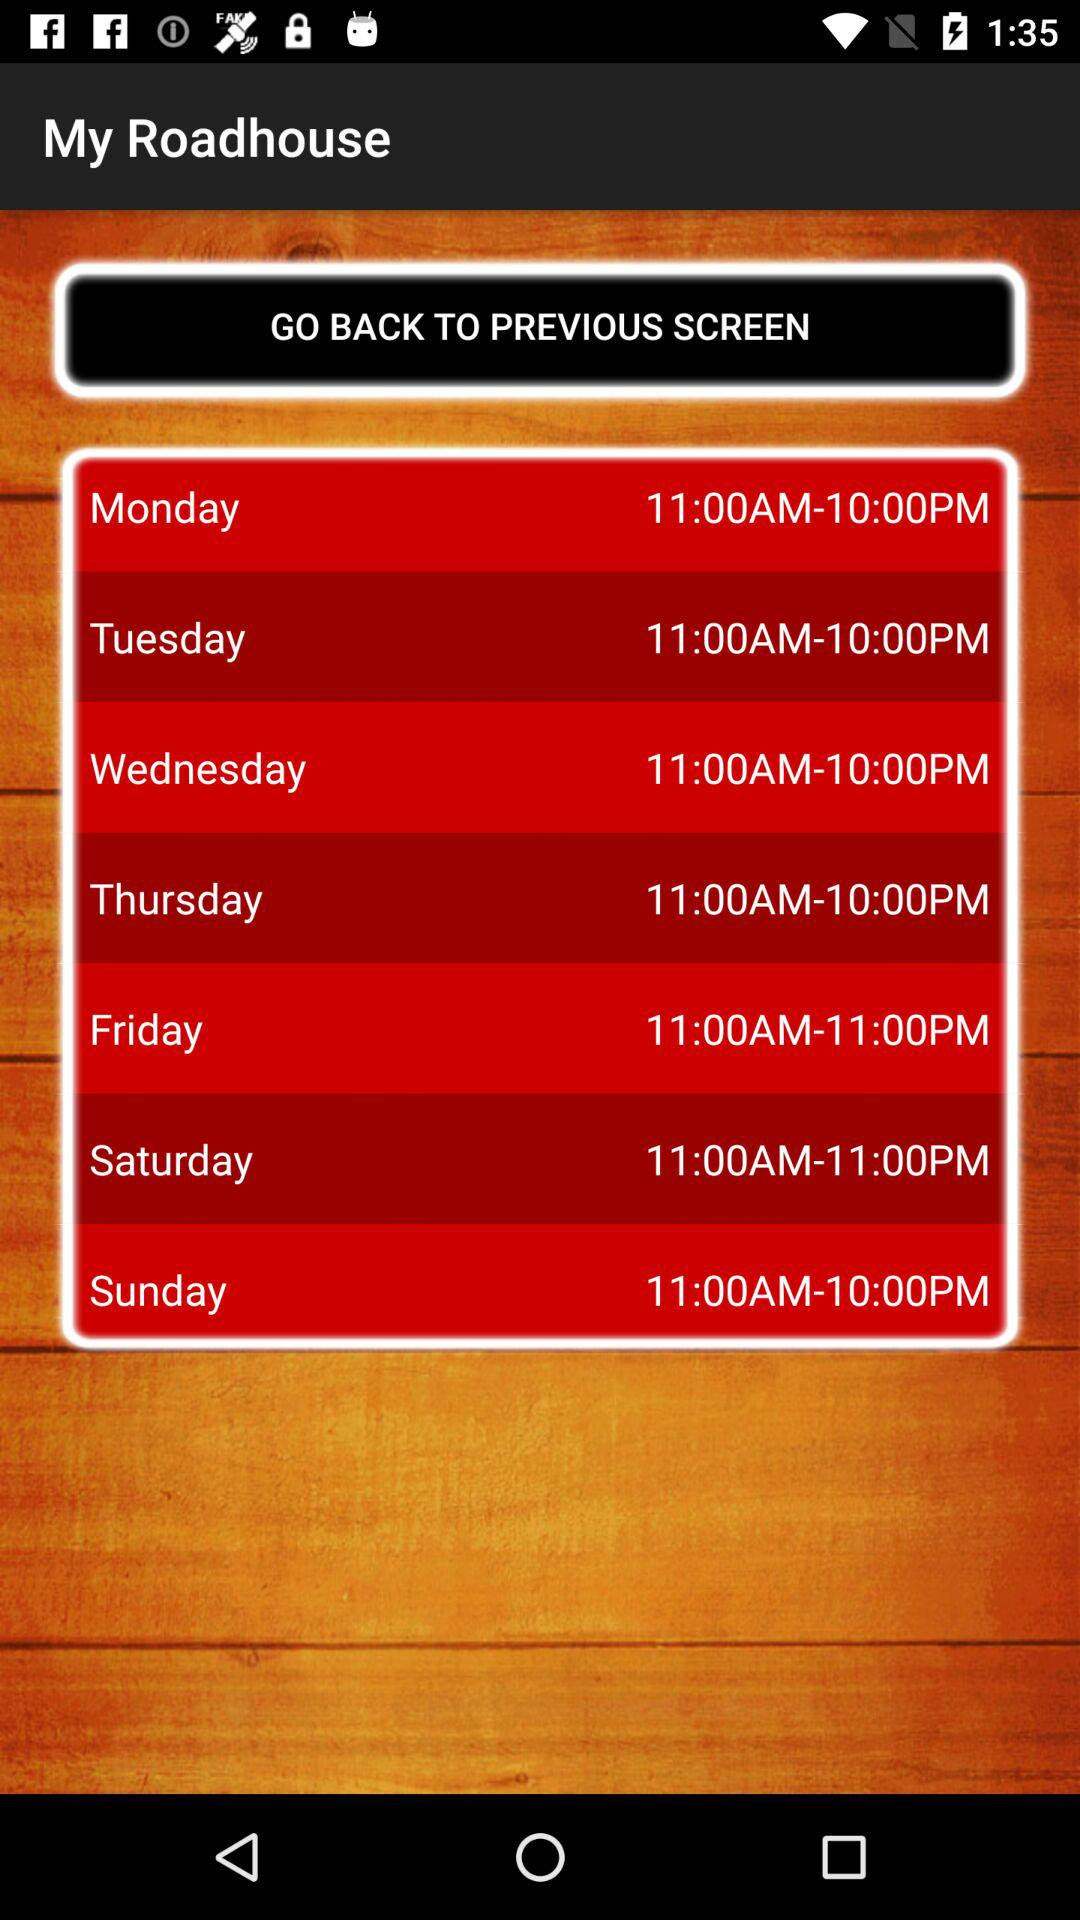Which days are selected?
When the provided information is insufficient, respond with <no answer>. <no answer> 